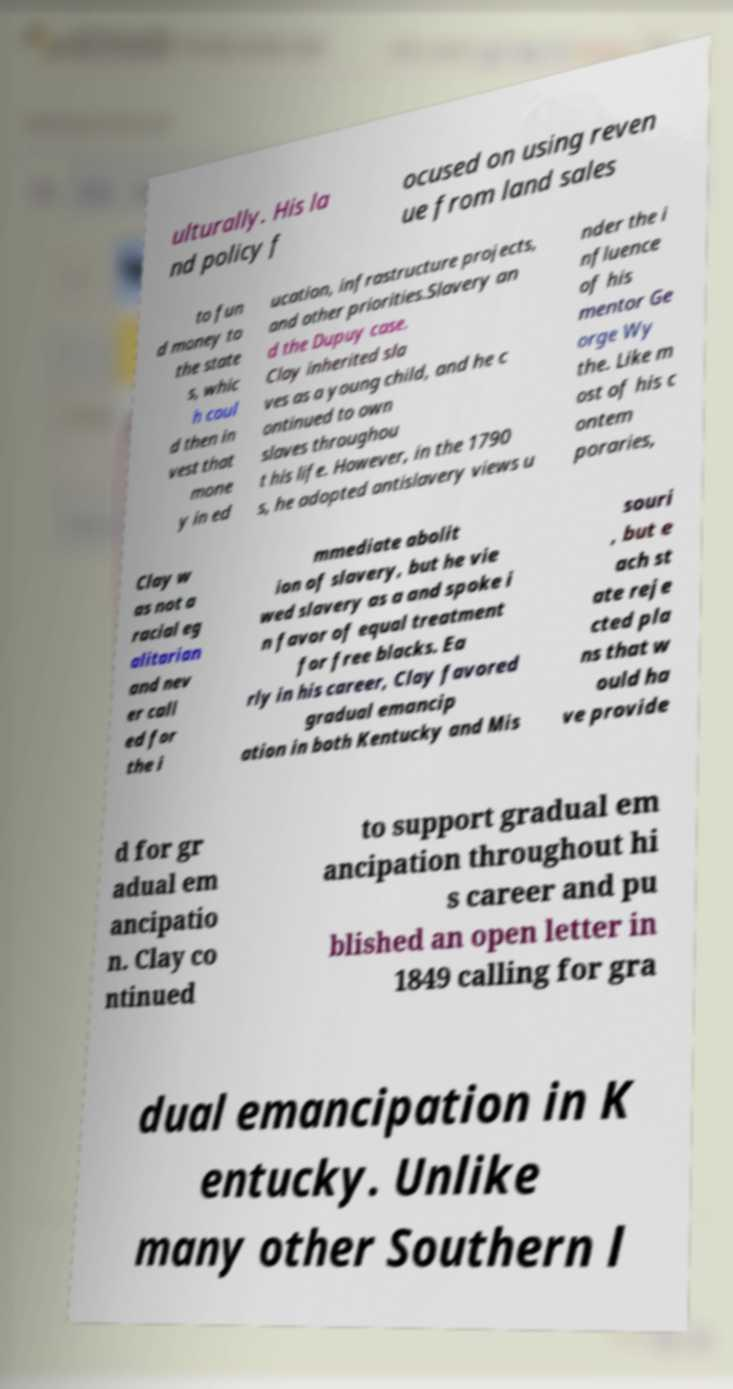There's text embedded in this image that I need extracted. Can you transcribe it verbatim? ulturally. His la nd policy f ocused on using reven ue from land sales to fun d money to the state s, whic h coul d then in vest that mone y in ed ucation, infrastructure projects, and other priorities.Slavery an d the Dupuy case. Clay inherited sla ves as a young child, and he c ontinued to own slaves throughou t his life. However, in the 1790 s, he adopted antislavery views u nder the i nfluence of his mentor Ge orge Wy the. Like m ost of his c ontem poraries, Clay w as not a racial eg alitarian and nev er call ed for the i mmediate abolit ion of slavery, but he vie wed slavery as a and spoke i n favor of equal treatment for free blacks. Ea rly in his career, Clay favored gradual emancip ation in both Kentucky and Mis souri , but e ach st ate reje cted pla ns that w ould ha ve provide d for gr adual em ancipatio n. Clay co ntinued to support gradual em ancipation throughout hi s career and pu blished an open letter in 1849 calling for gra dual emancipation in K entucky. Unlike many other Southern l 